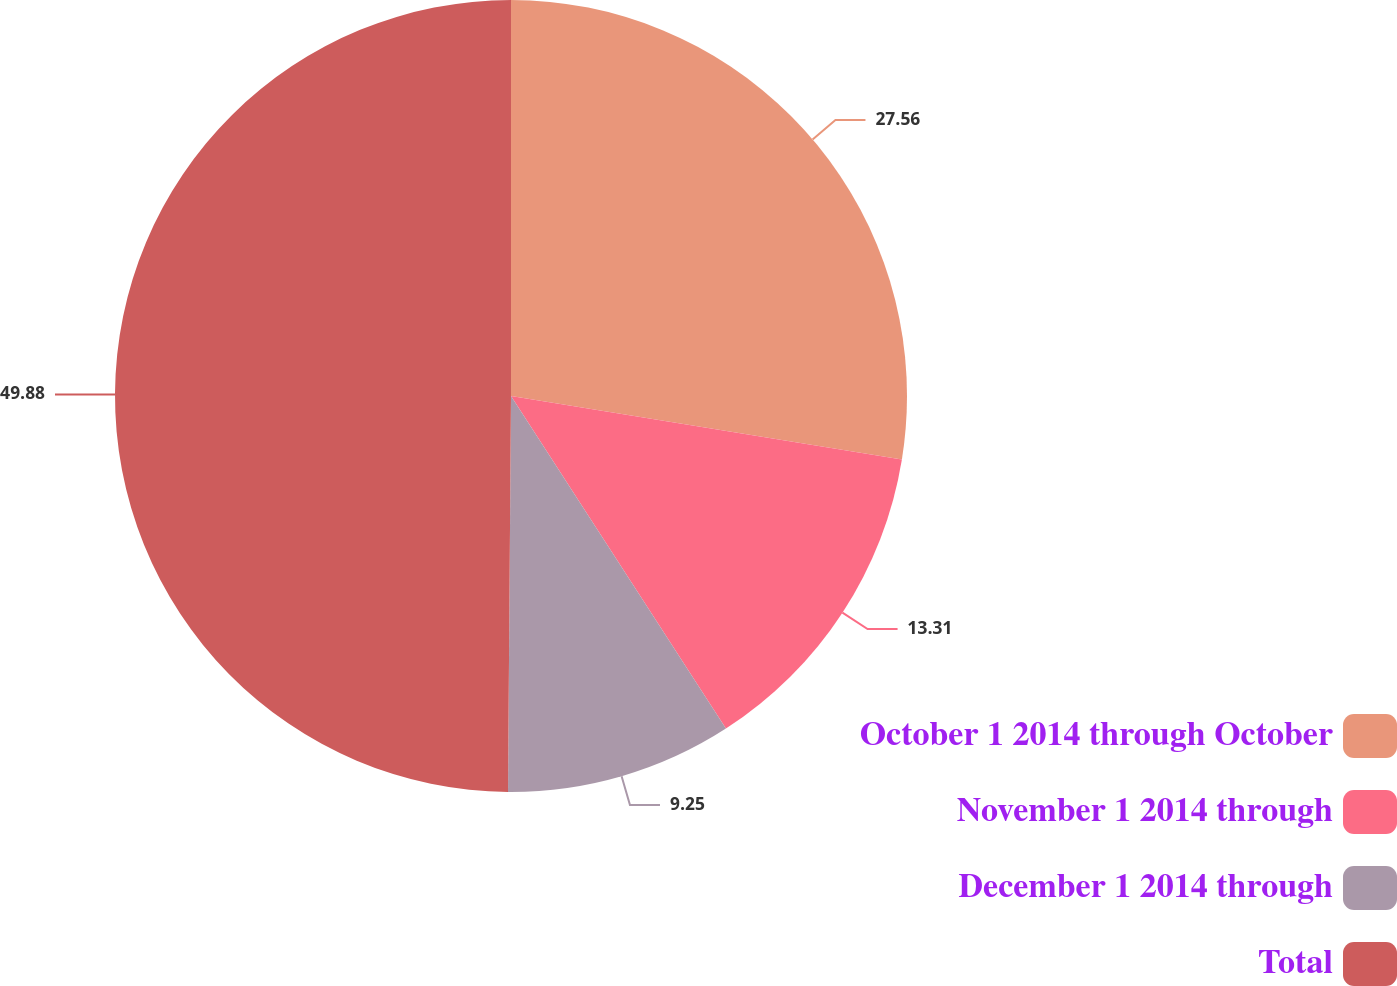<chart> <loc_0><loc_0><loc_500><loc_500><pie_chart><fcel>October 1 2014 through October<fcel>November 1 2014 through<fcel>December 1 2014 through<fcel>Total<nl><fcel>27.56%<fcel>13.31%<fcel>9.25%<fcel>49.88%<nl></chart> 